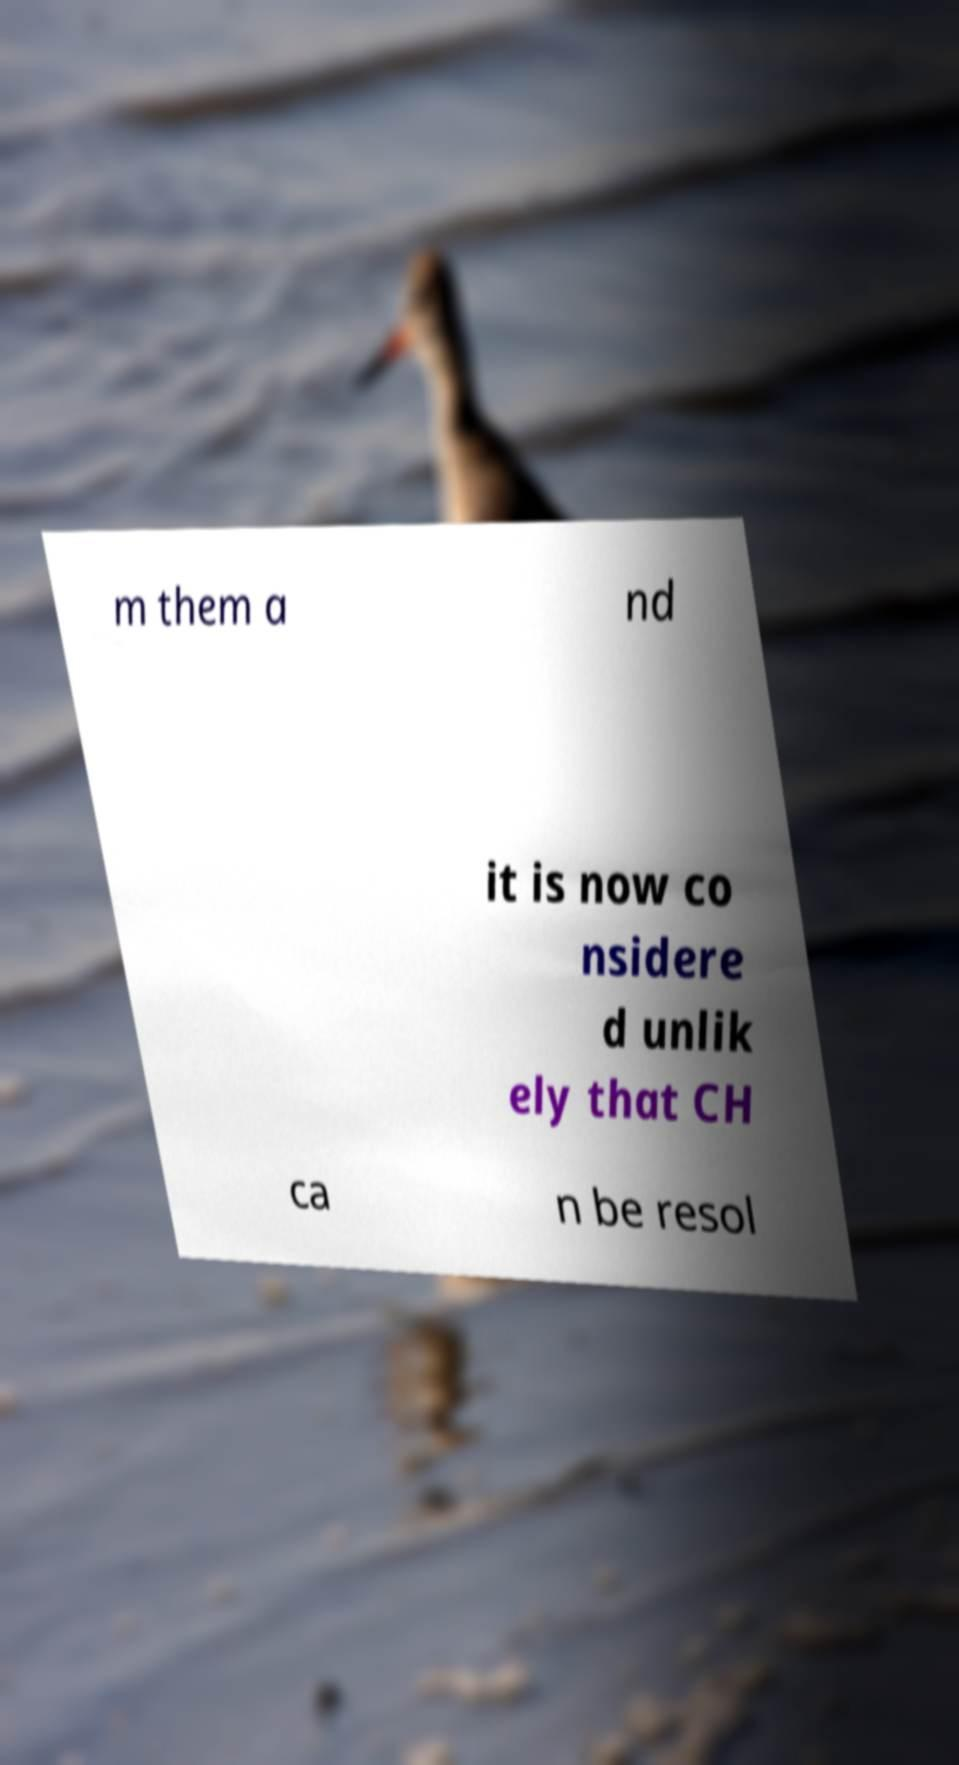Can you accurately transcribe the text from the provided image for me? m them a nd it is now co nsidere d unlik ely that CH ca n be resol 